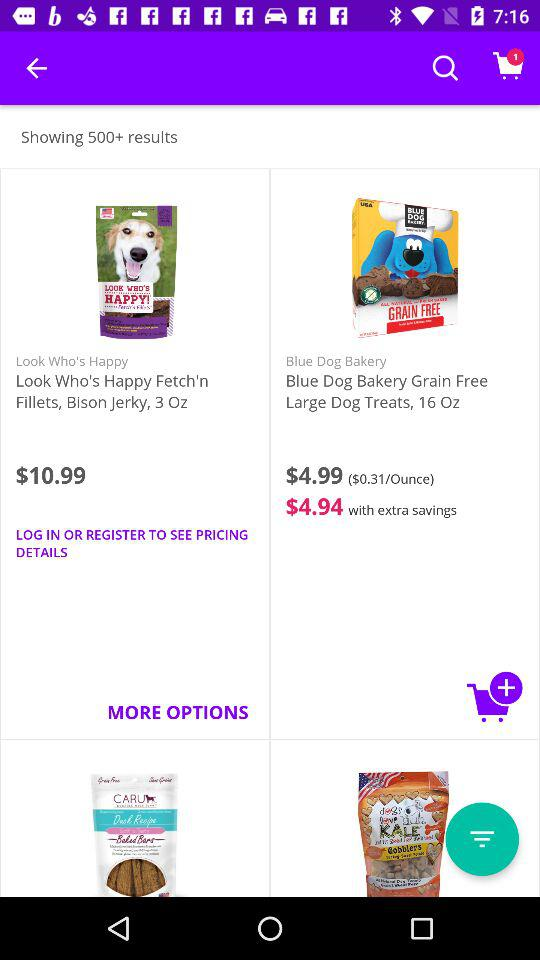How many results in total are there? There are more than 500 results. 